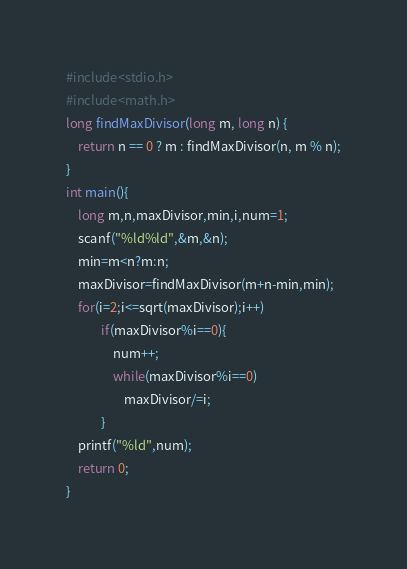Convert code to text. <code><loc_0><loc_0><loc_500><loc_500><_C_>#include<stdio.h>
#include<math.h>
long findMaxDivisor(long m, long n) {
	return n == 0 ? m : findMaxDivisor(n, m % n);
}
int main(){
	long m,n,maxDivisor,min,i,num=1;
	scanf("%ld%ld",&m,&n);
	min=m<n?m:n;
	maxDivisor=findMaxDivisor(m+n-min,min);
	for(i=2;i<=sqrt(maxDivisor);i++)
			if(maxDivisor%i==0){
				num++;
				while(maxDivisor%i==0)
					maxDivisor/=i;
			} 
	printf("%ld",num);
	return 0;
} </code> 